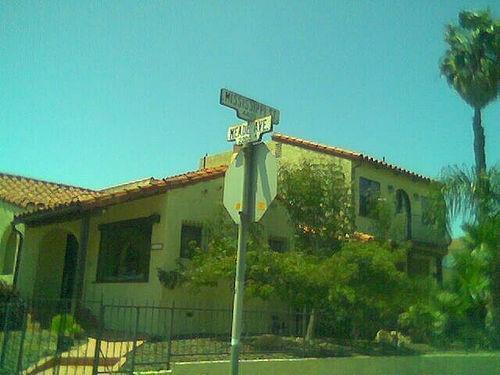How many people wear in orange?
Give a very brief answer. 0. 